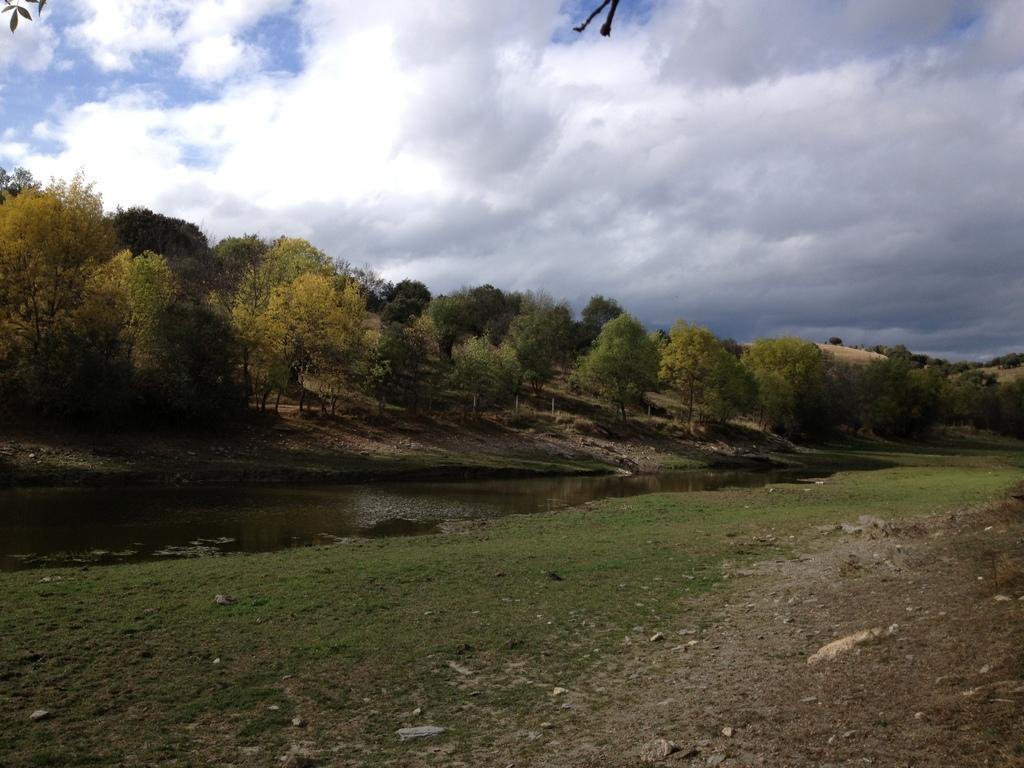Could you give a brief overview of what you see in this image? In this image there is grass, water, trees, and in the background there is sky. 